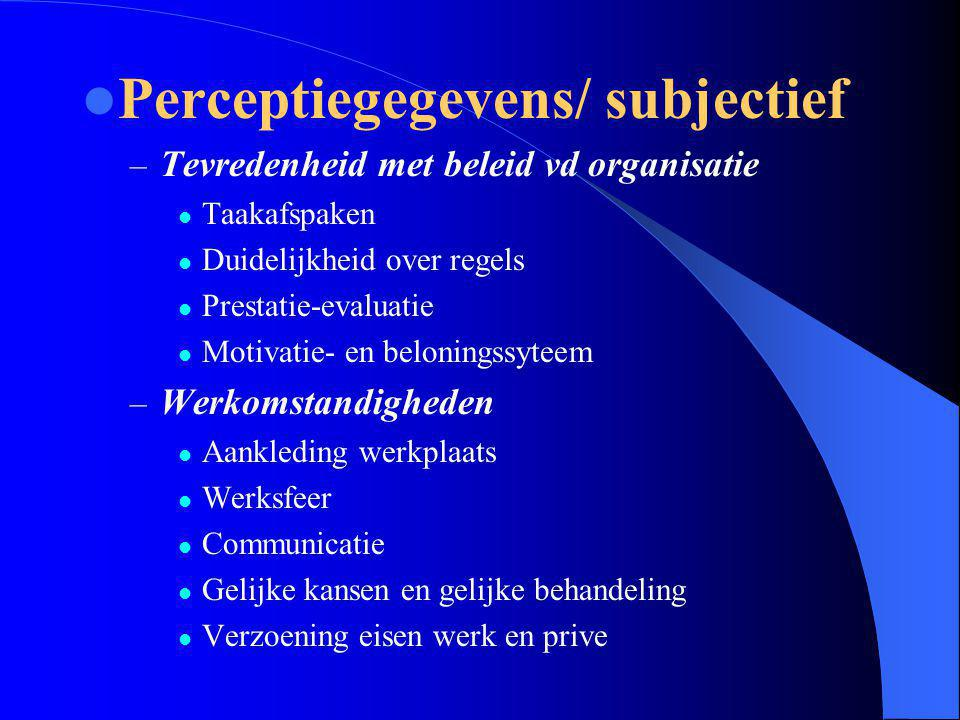Given the specific elements listed under "Tevredenheid met beleid vd organisatie," what could be a potential additional sub-bullet that would complement and enhance the understanding of an organization's policy satisfaction, considering the aspects already mentioned? A vital addition to the 'Tevredenheid met beleid vd organisatie' could be the inclusion of 'Feedback Mechanisms.' This would provide a structured avenue for employees to express their perceptions and experiences regarding the clarity of rules, task agreements, performance evaluations, and the motivation and reward system. Incorporating regular, structured feedback opportunities, such as quarterly surveys or suggestion boxes, ensures that management can gauge and improve the effectiveness of its policies, fostering a more adaptive and responsive organizational environment. 